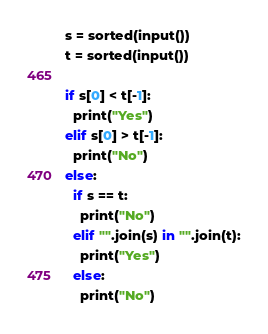<code> <loc_0><loc_0><loc_500><loc_500><_Python_>s = sorted(input())
t = sorted(input())

if s[0] < t[-1]:
  print("Yes")
elif s[0] > t[-1]:
  print("No")
else:
  if s == t:
    print("No")
  elif "".join(s) in "".join(t):
    print("Yes")
  else:
    print("No")</code> 